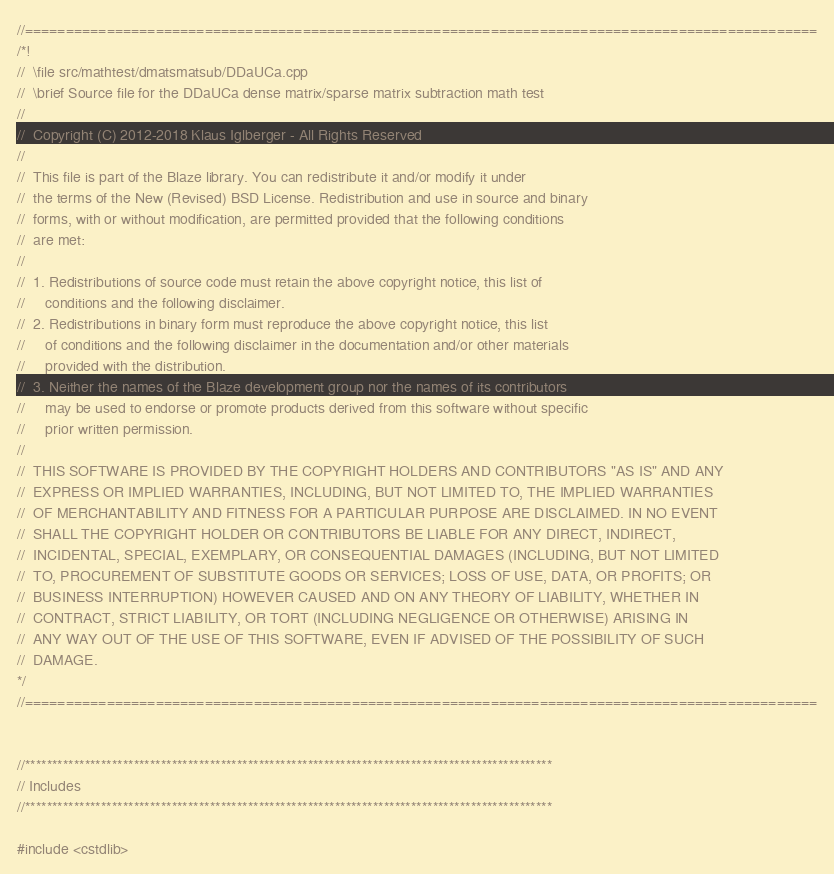Convert code to text. <code><loc_0><loc_0><loc_500><loc_500><_C++_>//=================================================================================================
/*!
//  \file src/mathtest/dmatsmatsub/DDaUCa.cpp
//  \brief Source file for the DDaUCa dense matrix/sparse matrix subtraction math test
//
//  Copyright (C) 2012-2018 Klaus Iglberger - All Rights Reserved
//
//  This file is part of the Blaze library. You can redistribute it and/or modify it under
//  the terms of the New (Revised) BSD License. Redistribution and use in source and binary
//  forms, with or without modification, are permitted provided that the following conditions
//  are met:
//
//  1. Redistributions of source code must retain the above copyright notice, this list of
//     conditions and the following disclaimer.
//  2. Redistributions in binary form must reproduce the above copyright notice, this list
//     of conditions and the following disclaimer in the documentation and/or other materials
//     provided with the distribution.
//  3. Neither the names of the Blaze development group nor the names of its contributors
//     may be used to endorse or promote products derived from this software without specific
//     prior written permission.
//
//  THIS SOFTWARE IS PROVIDED BY THE COPYRIGHT HOLDERS AND CONTRIBUTORS "AS IS" AND ANY
//  EXPRESS OR IMPLIED WARRANTIES, INCLUDING, BUT NOT LIMITED TO, THE IMPLIED WARRANTIES
//  OF MERCHANTABILITY AND FITNESS FOR A PARTICULAR PURPOSE ARE DISCLAIMED. IN NO EVENT
//  SHALL THE COPYRIGHT HOLDER OR CONTRIBUTORS BE LIABLE FOR ANY DIRECT, INDIRECT,
//  INCIDENTAL, SPECIAL, EXEMPLARY, OR CONSEQUENTIAL DAMAGES (INCLUDING, BUT NOT LIMITED
//  TO, PROCUREMENT OF SUBSTITUTE GOODS OR SERVICES; LOSS OF USE, DATA, OR PROFITS; OR
//  BUSINESS INTERRUPTION) HOWEVER CAUSED AND ON ANY THEORY OF LIABILITY, WHETHER IN
//  CONTRACT, STRICT LIABILITY, OR TORT (INCLUDING NEGLIGENCE OR OTHERWISE) ARISING IN
//  ANY WAY OUT OF THE USE OF THIS SOFTWARE, EVEN IF ADVISED OF THE POSSIBILITY OF SUCH
//  DAMAGE.
*/
//=================================================================================================


//*************************************************************************************************
// Includes
//*************************************************************************************************

#include <cstdlib></code> 